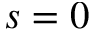Convert formula to latex. <formula><loc_0><loc_0><loc_500><loc_500>s = 0</formula> 